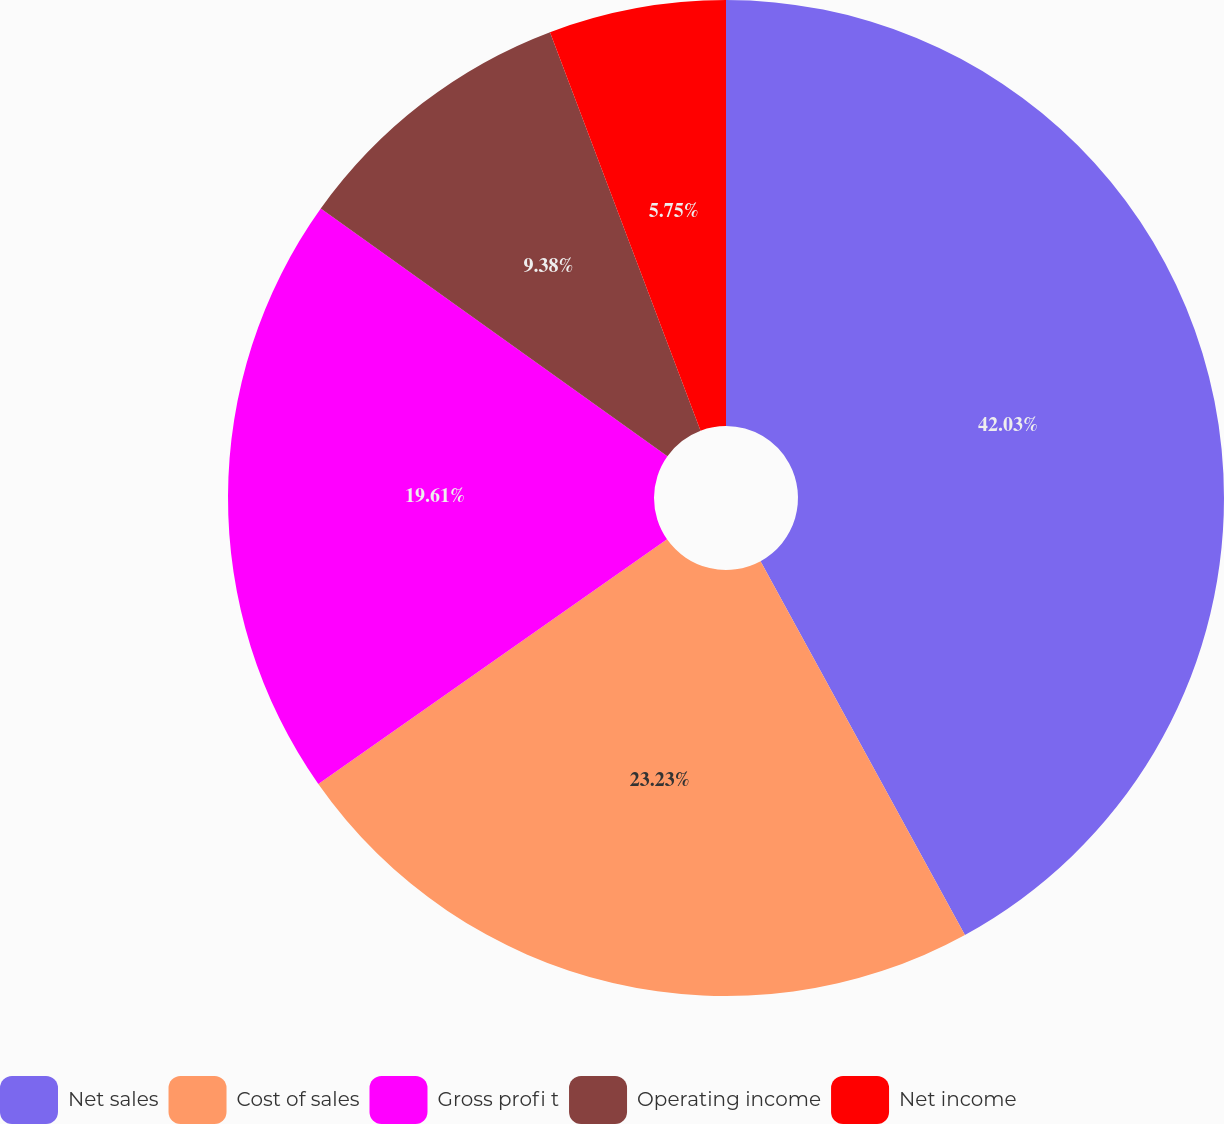Convert chart to OTSL. <chart><loc_0><loc_0><loc_500><loc_500><pie_chart><fcel>Net sales<fcel>Cost of sales<fcel>Gross profi t<fcel>Operating income<fcel>Net income<nl><fcel>42.04%<fcel>23.23%<fcel>19.61%<fcel>9.38%<fcel>5.75%<nl></chart> 